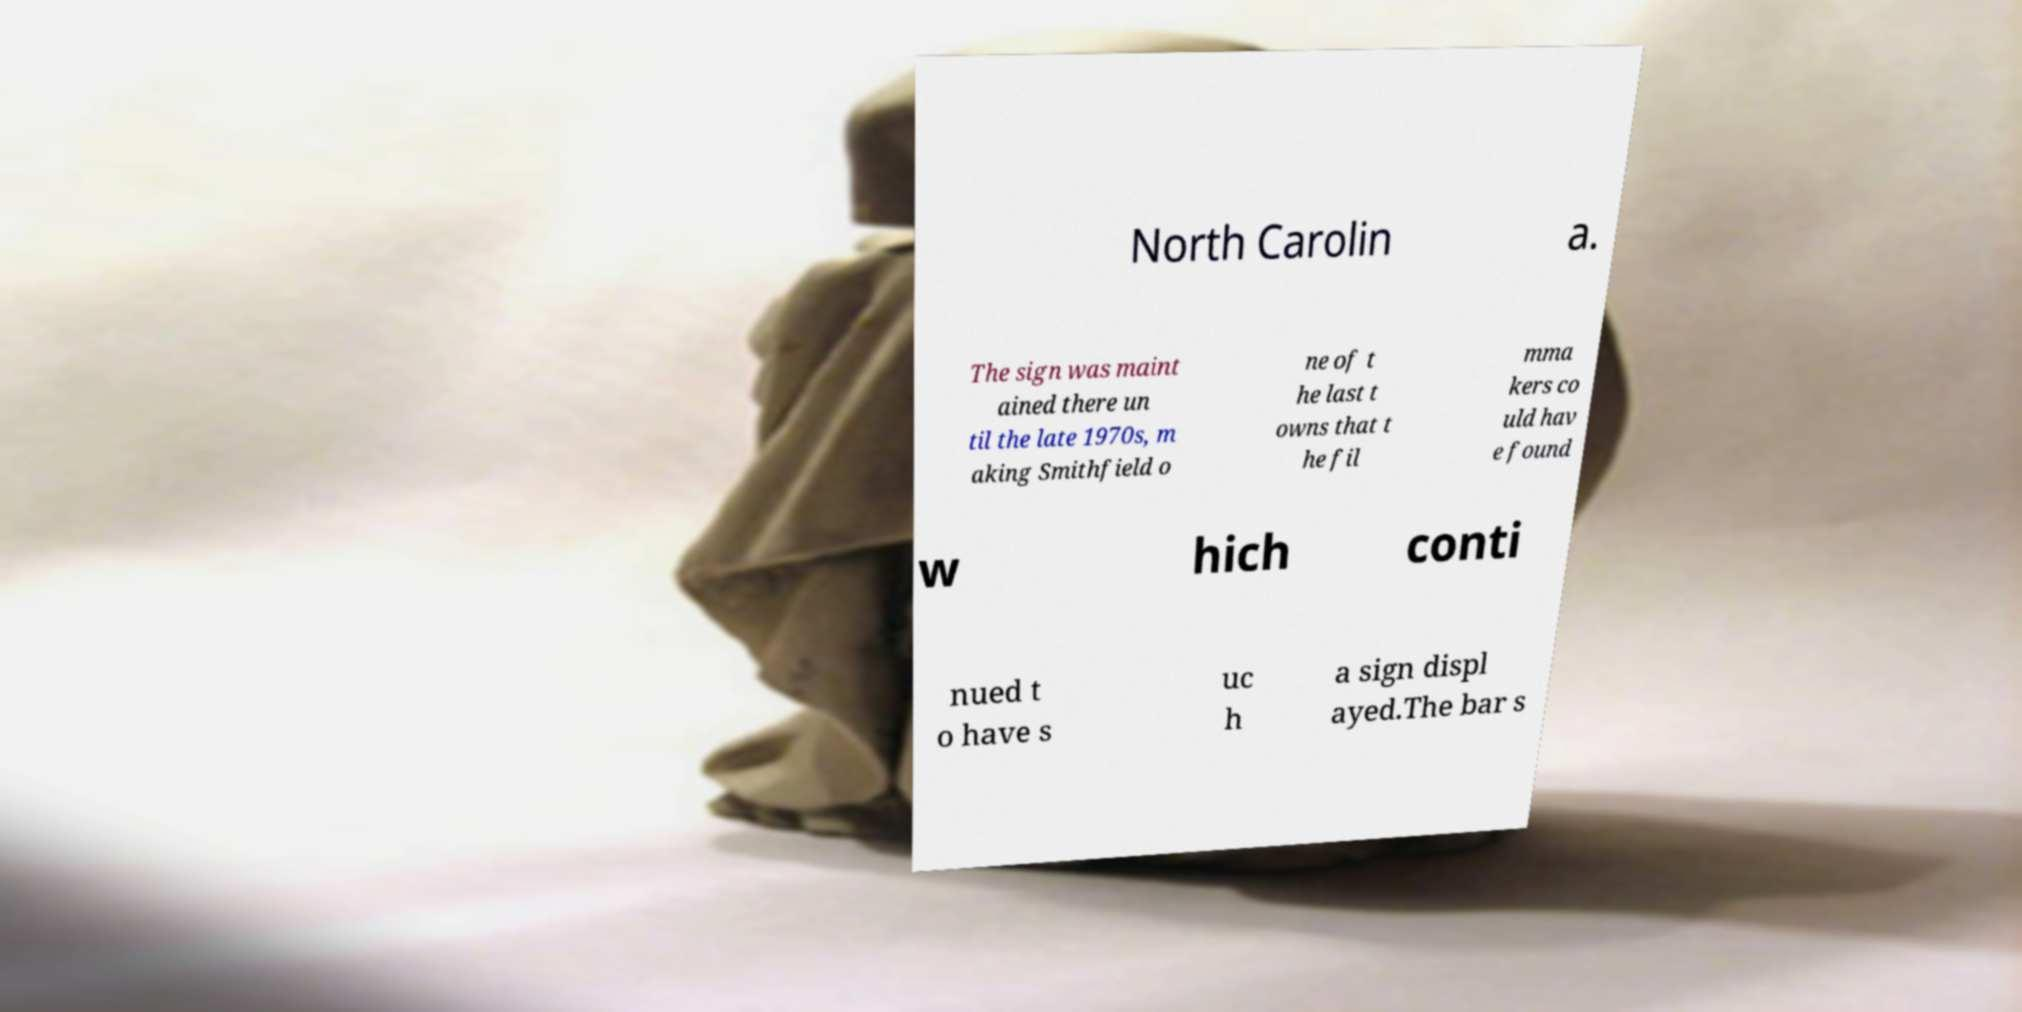Can you read and provide the text displayed in the image?This photo seems to have some interesting text. Can you extract and type it out for me? North Carolin a. The sign was maint ained there un til the late 1970s, m aking Smithfield o ne of t he last t owns that t he fil mma kers co uld hav e found w hich conti nued t o have s uc h a sign displ ayed.The bar s 